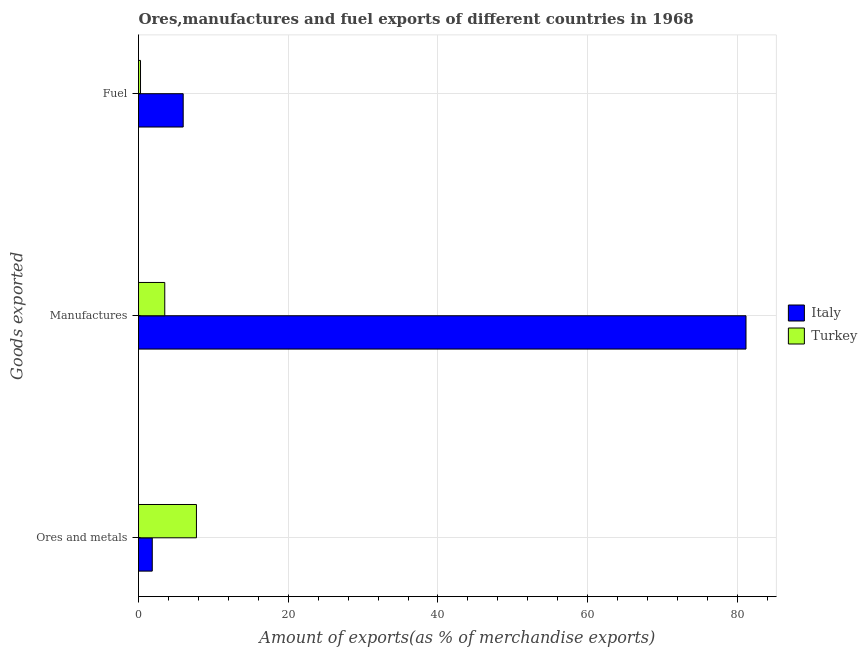How many groups of bars are there?
Provide a succinct answer. 3. Are the number of bars per tick equal to the number of legend labels?
Your response must be concise. Yes. How many bars are there on the 1st tick from the bottom?
Ensure brevity in your answer.  2. What is the label of the 2nd group of bars from the top?
Ensure brevity in your answer.  Manufactures. What is the percentage of fuel exports in Italy?
Offer a very short reply. 5.97. Across all countries, what is the maximum percentage of fuel exports?
Keep it short and to the point. 5.97. Across all countries, what is the minimum percentage of manufactures exports?
Keep it short and to the point. 3.51. What is the total percentage of fuel exports in the graph?
Keep it short and to the point. 6.24. What is the difference between the percentage of fuel exports in Italy and that in Turkey?
Make the answer very short. 5.7. What is the difference between the percentage of manufactures exports in Turkey and the percentage of ores and metals exports in Italy?
Provide a succinct answer. 1.67. What is the average percentage of manufactures exports per country?
Give a very brief answer. 42.33. What is the difference between the percentage of ores and metals exports and percentage of fuel exports in Italy?
Provide a short and direct response. -4.13. What is the ratio of the percentage of ores and metals exports in Italy to that in Turkey?
Make the answer very short. 0.24. Is the difference between the percentage of manufactures exports in Italy and Turkey greater than the difference between the percentage of ores and metals exports in Italy and Turkey?
Your response must be concise. Yes. What is the difference between the highest and the second highest percentage of manufactures exports?
Ensure brevity in your answer.  77.64. What is the difference between the highest and the lowest percentage of ores and metals exports?
Ensure brevity in your answer.  5.9. In how many countries, is the percentage of ores and metals exports greater than the average percentage of ores and metals exports taken over all countries?
Keep it short and to the point. 1. Is it the case that in every country, the sum of the percentage of ores and metals exports and percentage of manufactures exports is greater than the percentage of fuel exports?
Your response must be concise. Yes. How many bars are there?
Keep it short and to the point. 6. Are all the bars in the graph horizontal?
Your answer should be very brief. Yes. How many countries are there in the graph?
Make the answer very short. 2. What is the difference between two consecutive major ticks on the X-axis?
Provide a succinct answer. 20. Are the values on the major ticks of X-axis written in scientific E-notation?
Keep it short and to the point. No. Does the graph contain grids?
Your response must be concise. Yes. Where does the legend appear in the graph?
Your answer should be very brief. Center right. How many legend labels are there?
Keep it short and to the point. 2. What is the title of the graph?
Make the answer very short. Ores,manufactures and fuel exports of different countries in 1968. What is the label or title of the X-axis?
Make the answer very short. Amount of exports(as % of merchandise exports). What is the label or title of the Y-axis?
Give a very brief answer. Goods exported. What is the Amount of exports(as % of merchandise exports) in Italy in Ores and metals?
Provide a short and direct response. 1.84. What is the Amount of exports(as % of merchandise exports) in Turkey in Ores and metals?
Provide a succinct answer. 7.74. What is the Amount of exports(as % of merchandise exports) of Italy in Manufactures?
Provide a succinct answer. 81.15. What is the Amount of exports(as % of merchandise exports) of Turkey in Manufactures?
Provide a succinct answer. 3.51. What is the Amount of exports(as % of merchandise exports) of Italy in Fuel?
Offer a very short reply. 5.97. What is the Amount of exports(as % of merchandise exports) in Turkey in Fuel?
Provide a short and direct response. 0.27. Across all Goods exported, what is the maximum Amount of exports(as % of merchandise exports) in Italy?
Your answer should be very brief. 81.15. Across all Goods exported, what is the maximum Amount of exports(as % of merchandise exports) in Turkey?
Offer a very short reply. 7.74. Across all Goods exported, what is the minimum Amount of exports(as % of merchandise exports) in Italy?
Provide a short and direct response. 1.84. Across all Goods exported, what is the minimum Amount of exports(as % of merchandise exports) of Turkey?
Your response must be concise. 0.27. What is the total Amount of exports(as % of merchandise exports) of Italy in the graph?
Ensure brevity in your answer.  88.95. What is the total Amount of exports(as % of merchandise exports) in Turkey in the graph?
Make the answer very short. 11.52. What is the difference between the Amount of exports(as % of merchandise exports) of Italy in Ores and metals and that in Manufactures?
Offer a terse response. -79.31. What is the difference between the Amount of exports(as % of merchandise exports) of Turkey in Ores and metals and that in Manufactures?
Keep it short and to the point. 4.23. What is the difference between the Amount of exports(as % of merchandise exports) in Italy in Ores and metals and that in Fuel?
Provide a short and direct response. -4.13. What is the difference between the Amount of exports(as % of merchandise exports) in Turkey in Ores and metals and that in Fuel?
Provide a succinct answer. 7.47. What is the difference between the Amount of exports(as % of merchandise exports) in Italy in Manufactures and that in Fuel?
Your answer should be compact. 75.18. What is the difference between the Amount of exports(as % of merchandise exports) in Turkey in Manufactures and that in Fuel?
Offer a terse response. 3.24. What is the difference between the Amount of exports(as % of merchandise exports) of Italy in Ores and metals and the Amount of exports(as % of merchandise exports) of Turkey in Manufactures?
Give a very brief answer. -1.67. What is the difference between the Amount of exports(as % of merchandise exports) in Italy in Ores and metals and the Amount of exports(as % of merchandise exports) in Turkey in Fuel?
Provide a short and direct response. 1.57. What is the difference between the Amount of exports(as % of merchandise exports) of Italy in Manufactures and the Amount of exports(as % of merchandise exports) of Turkey in Fuel?
Make the answer very short. 80.88. What is the average Amount of exports(as % of merchandise exports) of Italy per Goods exported?
Ensure brevity in your answer.  29.65. What is the average Amount of exports(as % of merchandise exports) in Turkey per Goods exported?
Offer a terse response. 3.84. What is the difference between the Amount of exports(as % of merchandise exports) of Italy and Amount of exports(as % of merchandise exports) of Turkey in Ores and metals?
Ensure brevity in your answer.  -5.9. What is the difference between the Amount of exports(as % of merchandise exports) of Italy and Amount of exports(as % of merchandise exports) of Turkey in Manufactures?
Provide a succinct answer. 77.64. What is the difference between the Amount of exports(as % of merchandise exports) of Italy and Amount of exports(as % of merchandise exports) of Turkey in Fuel?
Offer a very short reply. 5.7. What is the ratio of the Amount of exports(as % of merchandise exports) of Italy in Ores and metals to that in Manufactures?
Make the answer very short. 0.02. What is the ratio of the Amount of exports(as % of merchandise exports) of Turkey in Ores and metals to that in Manufactures?
Your answer should be very brief. 2.21. What is the ratio of the Amount of exports(as % of merchandise exports) in Italy in Ores and metals to that in Fuel?
Keep it short and to the point. 0.31. What is the ratio of the Amount of exports(as % of merchandise exports) in Turkey in Ores and metals to that in Fuel?
Your response must be concise. 28.8. What is the ratio of the Amount of exports(as % of merchandise exports) of Italy in Manufactures to that in Fuel?
Your answer should be compact. 13.59. What is the ratio of the Amount of exports(as % of merchandise exports) in Turkey in Manufactures to that in Fuel?
Ensure brevity in your answer.  13.06. What is the difference between the highest and the second highest Amount of exports(as % of merchandise exports) of Italy?
Provide a succinct answer. 75.18. What is the difference between the highest and the second highest Amount of exports(as % of merchandise exports) in Turkey?
Provide a succinct answer. 4.23. What is the difference between the highest and the lowest Amount of exports(as % of merchandise exports) of Italy?
Your answer should be compact. 79.31. What is the difference between the highest and the lowest Amount of exports(as % of merchandise exports) of Turkey?
Give a very brief answer. 7.47. 